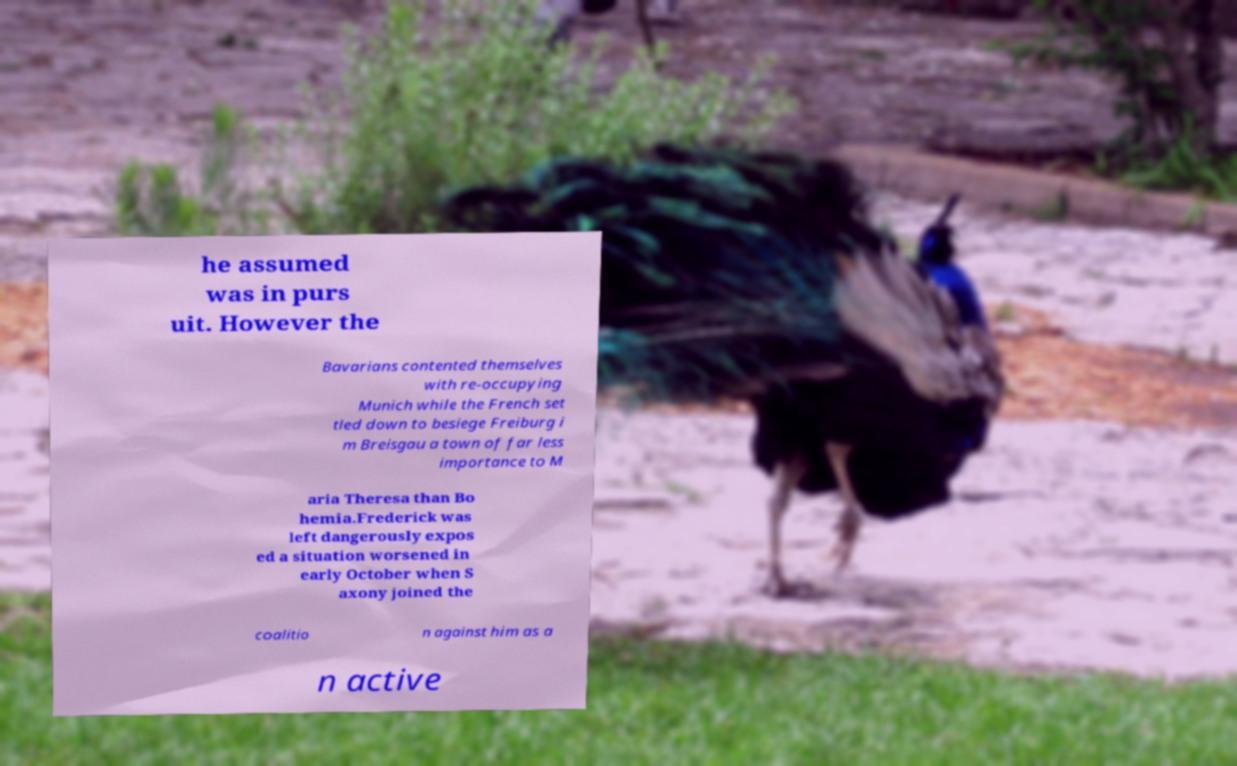I need the written content from this picture converted into text. Can you do that? he assumed was in purs uit. However the Bavarians contented themselves with re-occupying Munich while the French set tled down to besiege Freiburg i m Breisgau a town of far less importance to M aria Theresa than Bo hemia.Frederick was left dangerously expos ed a situation worsened in early October when S axony joined the coalitio n against him as a n active 